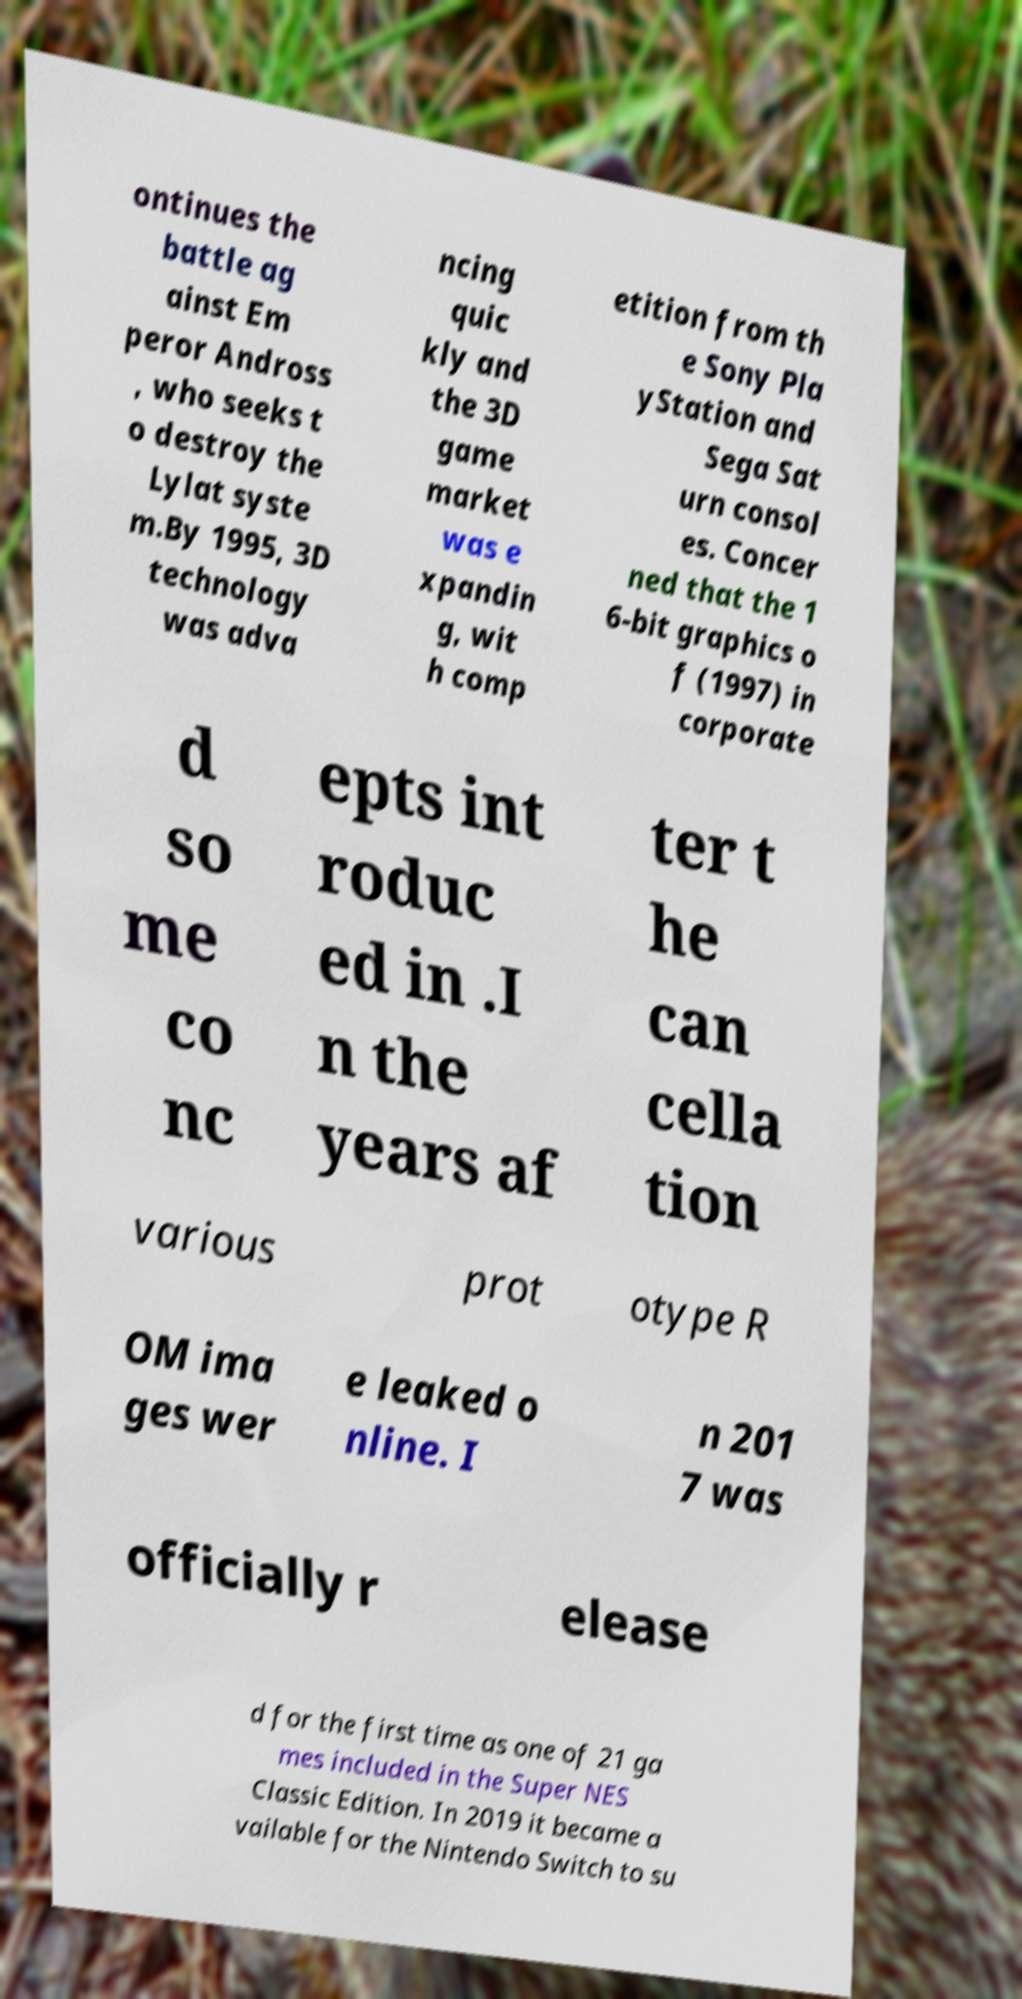Please read and relay the text visible in this image. What does it say? ontinues the battle ag ainst Em peror Andross , who seeks t o destroy the Lylat syste m.By 1995, 3D technology was adva ncing quic kly and the 3D game market was e xpandin g, wit h comp etition from th e Sony Pla yStation and Sega Sat urn consol es. Concer ned that the 1 6-bit graphics o f (1997) in corporate d so me co nc epts int roduc ed in .I n the years af ter t he can cella tion various prot otype R OM ima ges wer e leaked o nline. I n 201 7 was officially r elease d for the first time as one of 21 ga mes included in the Super NES Classic Edition. In 2019 it became a vailable for the Nintendo Switch to su 